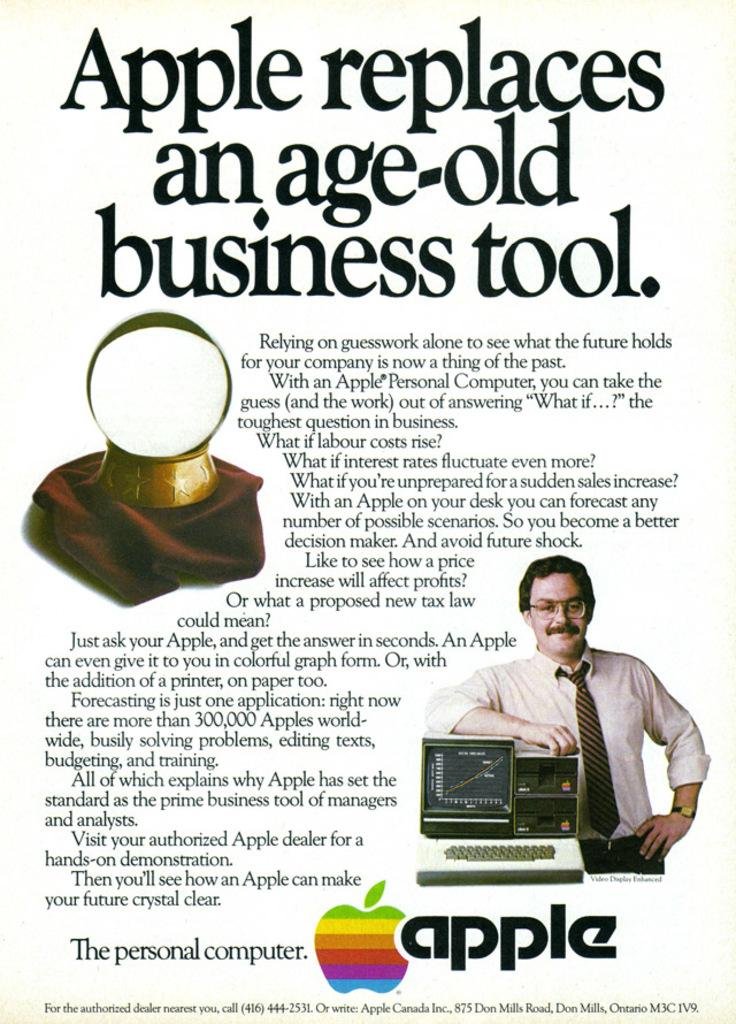<image>
Summarize the visual content of the image. An old Apple advertisement with the statement "Apple replaces and age old business tool" on top. 